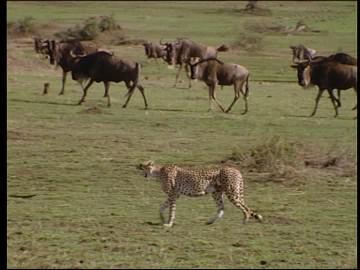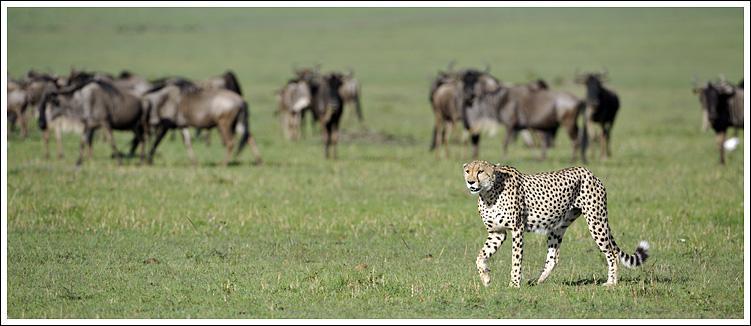The first image is the image on the left, the second image is the image on the right. Given the left and right images, does the statement "a wildebeest is being held by two cheetahs" hold true? Answer yes or no. No. The first image is the image on the left, the second image is the image on the right. Assess this claim about the two images: "An image shows a spotted wildcat standing on its hind legs, with its front paws grasping a horned animal.". Correct or not? Answer yes or no. No. 